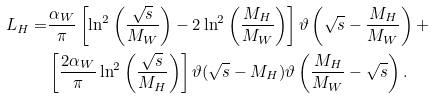<formula> <loc_0><loc_0><loc_500><loc_500>L _ { H } = & \frac { \alpha _ { W } } { \pi } \left [ \ln ^ { 2 } \left ( \frac { \sqrt { s } } { M _ { W } } \right ) - 2 \ln ^ { 2 } \left ( \frac { M _ { H } } { M _ { W } } \right ) \right ] \vartheta \left ( \sqrt { s } - \frac { M _ { H } } { M _ { W } } \right ) + \\ & \left [ \frac { 2 \alpha _ { W } } { \pi } \ln ^ { 2 } \left ( \frac { \sqrt { s } } { M _ { H } } \right ) \right ] \vartheta ( \sqrt { s } - M _ { H } ) \vartheta \left ( \frac { M _ { H } } { M _ { W } } - \sqrt { s } \right ) .</formula> 